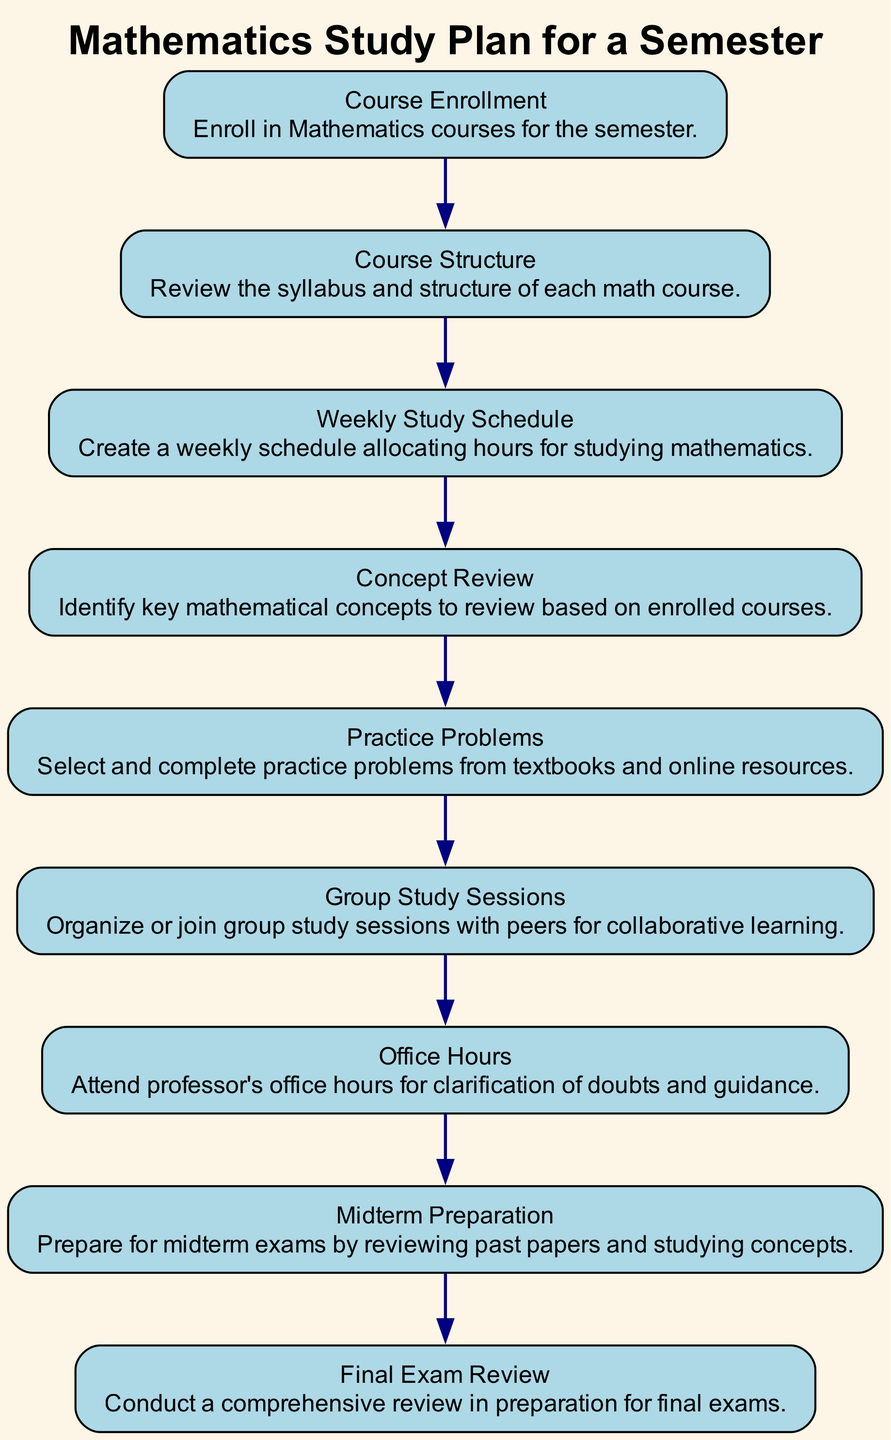What is the first element in the diagram? The first element listed in the diagram is "Course Enrollment". This can be identified by looking at the top of the flow chart where the flow begins.
Answer: Course Enrollment How many elements are there in total in the diagram? By counting the nodes in the flow chart, we find there are ten elements included. Each element represents a distinct step in the study plan.
Answer: Ten What does the arrow from "Course Enrollment" point to? The arrow from "Course Enrollment" points to "Course Structure", indicating the next step in the study plan after enrolling in courses.
Answer: Course Structure Which element comes before "Midterm Preparation"? The element "Office Hours" comes directly before "Midterm Preparation" in the flow chart, indicating that students should attend office hours to clarify doubts before preparing for midterms.
Answer: Office Hours What is the last element in the diagram? The last element is "Final Exam Review", which indicates the final step in the mathematics study plan for the semester.
Answer: Final Exam Review Which two elements are directly connected before "Final Exam Review"? The two elements connected before "Final Exam Review" are "Midterm Preparation" and "Practice Problems". The flow shows that both precede the final exam review.
Answer: Midterm Preparation and Practice Problems What types of activities does "Group Study Sessions" involve? "Group Study Sessions" involves collaborative learning and organizing or joining sessions with peers. This implies a teamwork-based approach to studying mathematics.
Answer: Collaborative learning What is the purpose of "Office Hours" in this study plan? "Office Hours" is for clarification of doubts and guidance by attending the professor's designated hours, helping students understand course material better.
Answer: Clarification of doubts What process is suggested immediately after "Concept Review"? After "Concept Review", the next suggested process is "Practice Problems", indicating that students should apply their understanding of concepts through practice.
Answer: Practice Problems 